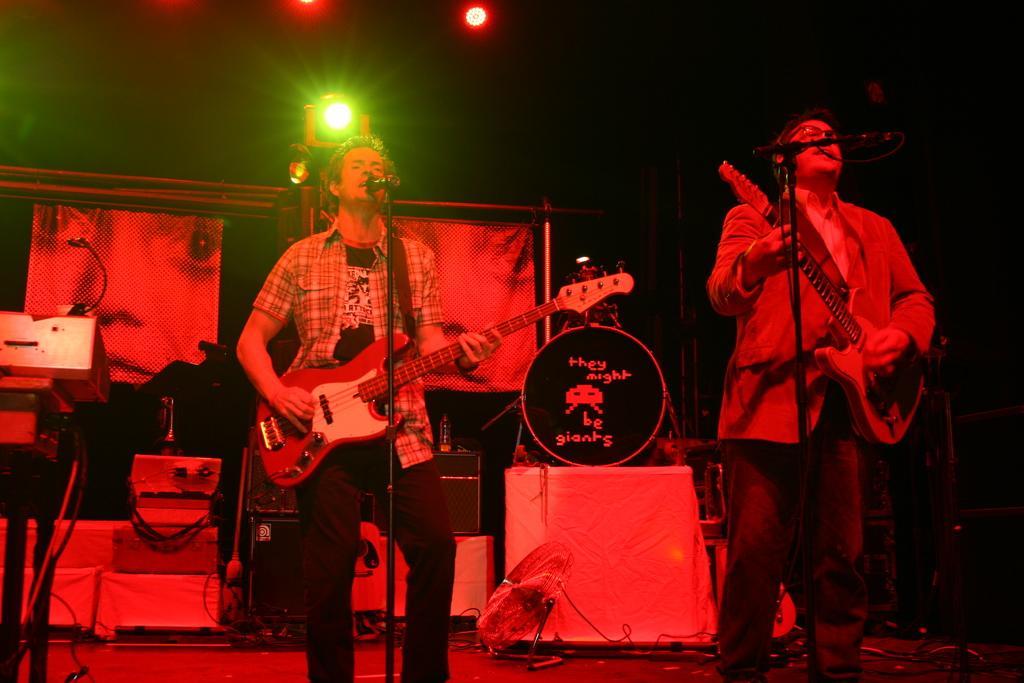Please provide a concise description of this image. This is a picture taken on a stage, there are two persons holding the guitars and singing a song in front of this people there is a microphone with stand. Background of this people there are music instrument and a banner with light. 